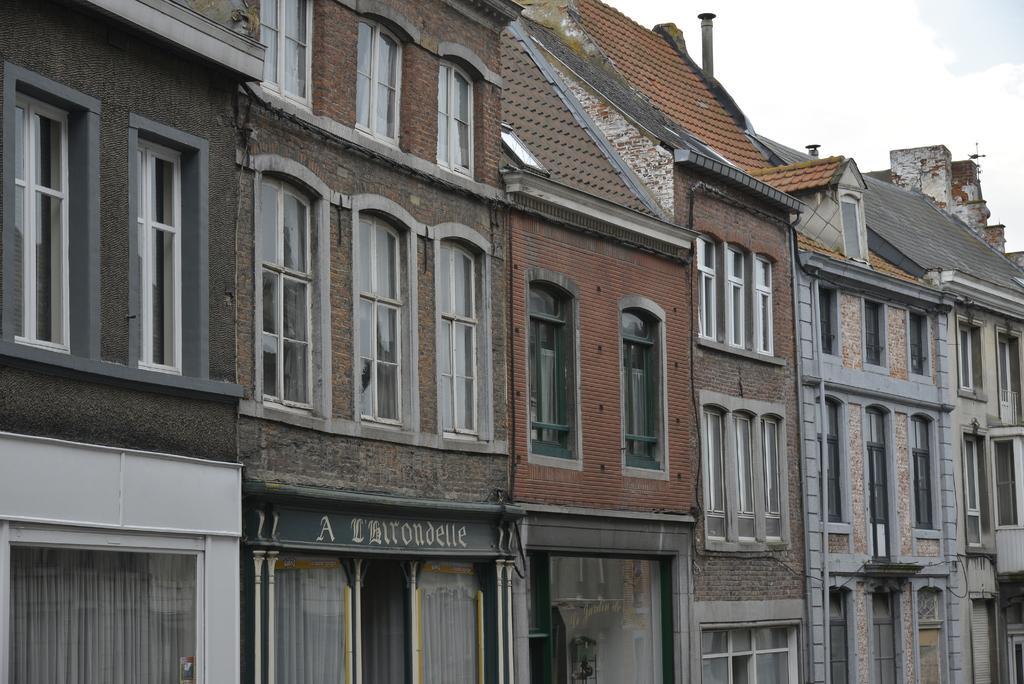How would you summarize this image in a sentence or two? In this image we can see a building and windows. In the background there is sky with clouds. 